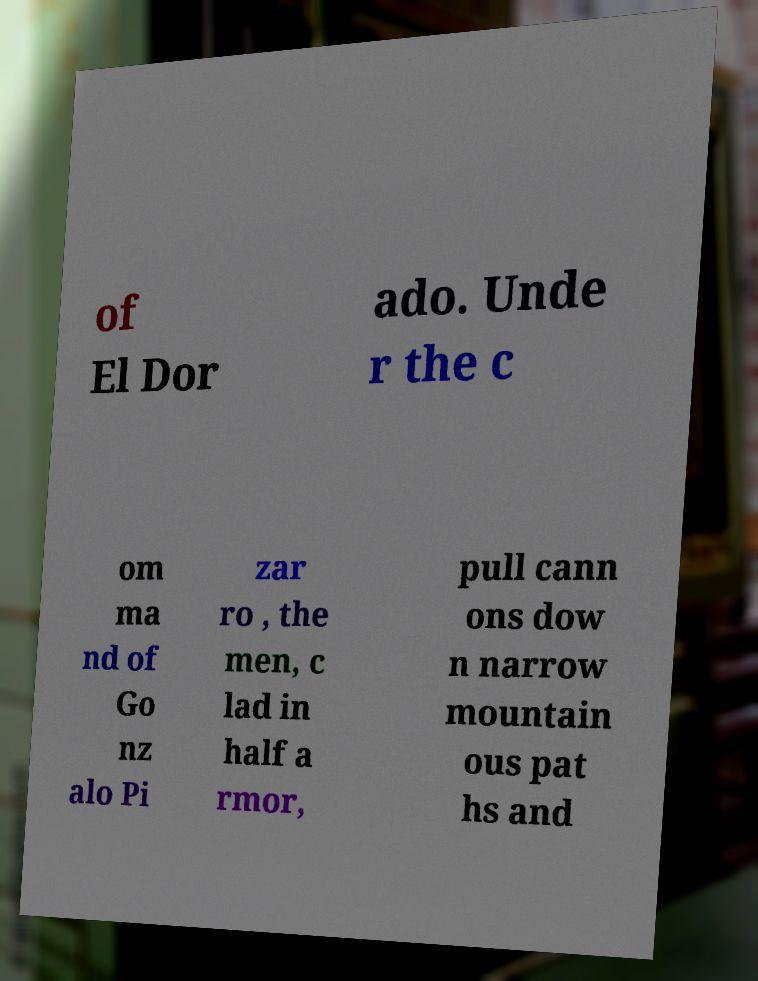What messages or text are displayed in this image? I need them in a readable, typed format. of El Dor ado. Unde r the c om ma nd of Go nz alo Pi zar ro , the men, c lad in half a rmor, pull cann ons dow n narrow mountain ous pat hs and 